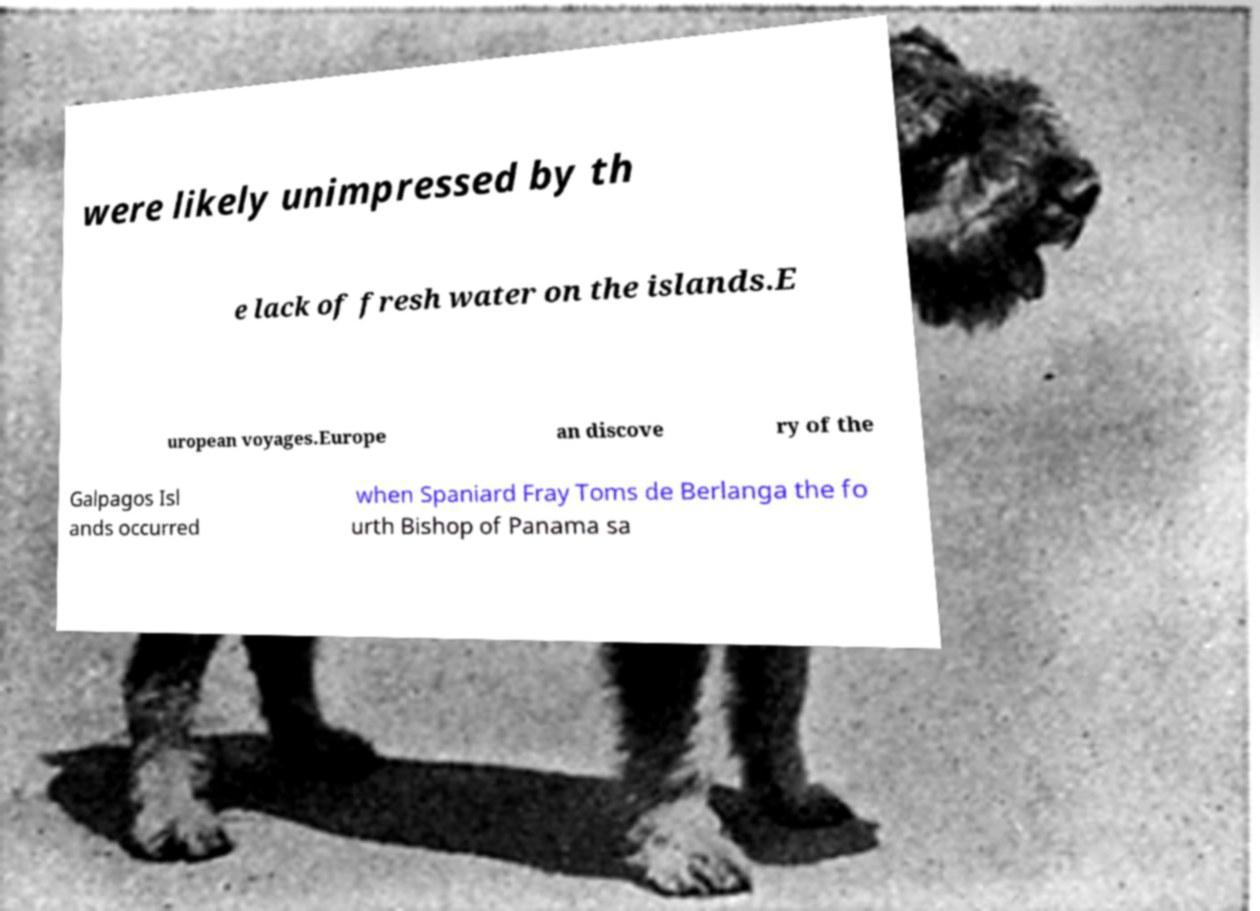What messages or text are displayed in this image? I need them in a readable, typed format. were likely unimpressed by th e lack of fresh water on the islands.E uropean voyages.Europe an discove ry of the Galpagos Isl ands occurred when Spaniard Fray Toms de Berlanga the fo urth Bishop of Panama sa 